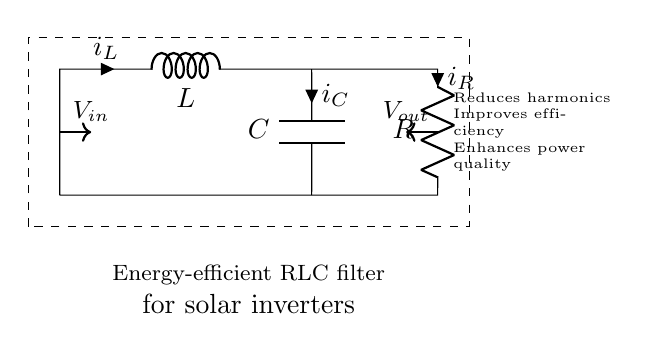What is the type of filter shown in this diagram? The circuit diagram represents an RLC filter, which consists of a resistor, inductor, and capacitor connected in a specific configuration to filter out unwanted frequencies.
Answer: RLC filter What are the components used in this circuit? The circuit comprises three components: a resistor, an inductor, and a capacitor. These are identified by the labels and symbols used in the diagram.
Answer: Resistor, inductor, capacitor What is the role of the inductor in this filter? The inductor in the RLC filter typically opposes changes in current, creating an impedance that influences the filter's behavior in relation to frequency, contributing to the attenuation or amplification of certain frequencies.
Answer: Opposes current changes What is the voltage input to the circuit? The voltage input is labeled as V in the circuit, indicating it is the voltage source connected at the input terminal, supplying power to the circuit.
Answer: V in How does this filter improve energy efficiency? The RLC filter reduces harmonics generated by the inverter, leading to lower energy losses and improved performance, which contributes to overall energy efficiency in solar systems.
Answer: Reduces harmonics What is the current through the resistor denoted as? The current through the resistor in the circuit is denoted as i sub r, as indicated in the diagram, representing the electric current flowing through that component.
Answer: i sub r What effect does the capacitor have in this configuration? The capacitor in the circuit has the role of storing and releasing electrical energy, which helps in balancing the reactive power and improves the power quality by filtering out high-frequency noise.
Answer: Filters high-frequency noise 